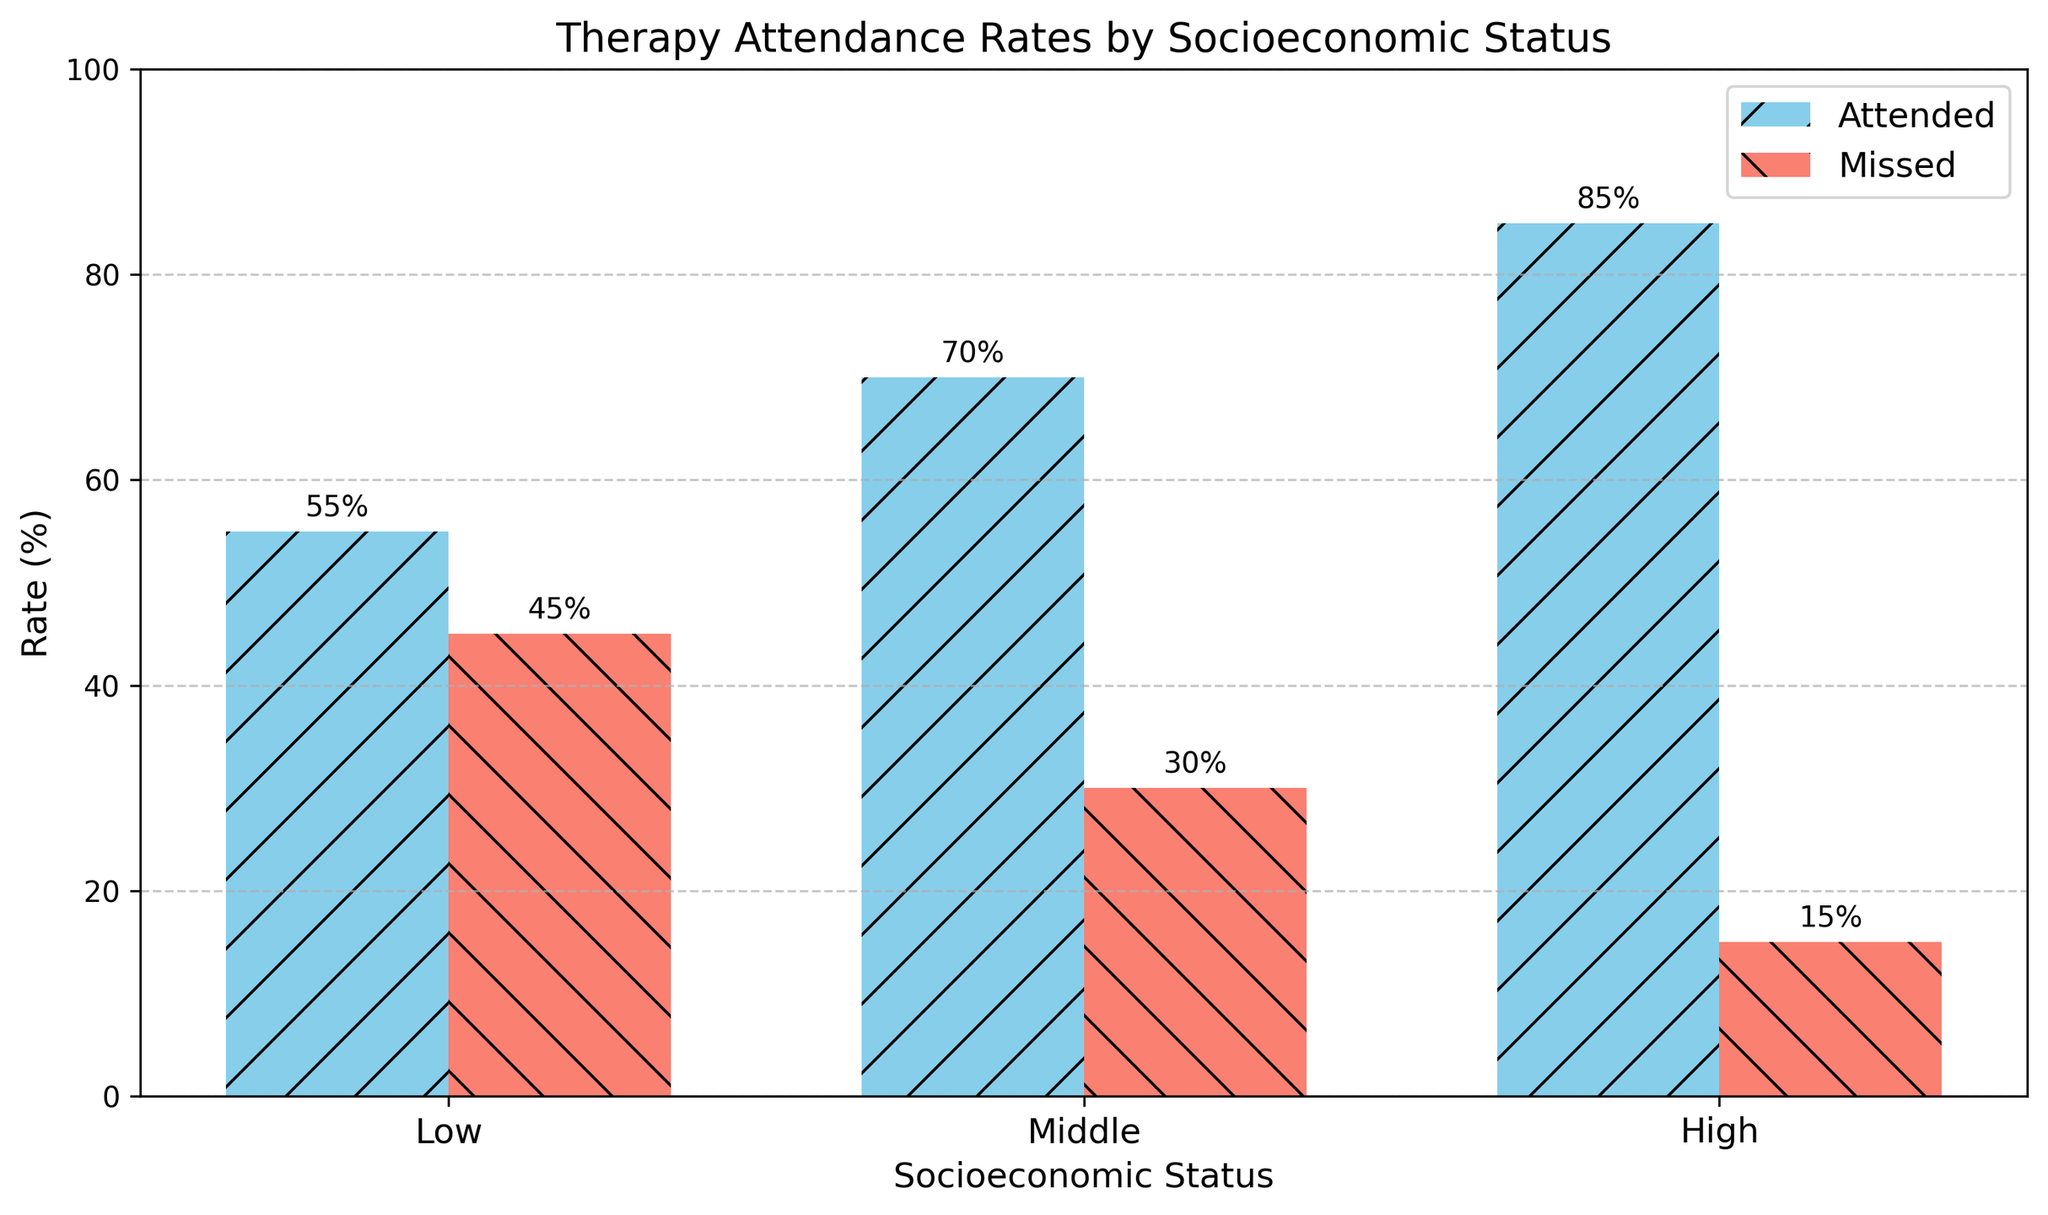What is the attendance rate for individuals from the middle socioeconomic status? The bar for the middle socioeconomic status labeled "Attended" shows a height representing the attendance rate. This value is 70%, as indicated by the data label on the bar.
Answer: 70% Which socioeconomic status group has the lowest missed therapy rate? By comparing the heights of the "Missed" bars for all socioeconomic status groups, the bar for the "High" group is the shortest, indicating the lowest missed rate.
Answer: High How much higher is the attendance rate for the high socioeconomic status group compared to the low socioeconomic status group? Subtract the attendance rate percentage of the low group from that of the high group (85% - 55%).
Answer: 30% What is the combined missed therapy rate for all socioeconomic status groups? Add the missed rates for all socioeconomic status groups: 45% (Low) + 30% (Middle) + 15% (High).
Answer: 90% What is the difference between the attendance and missed rates for the middle socioeconomic status group? Subtract the missed rate of the middle group from the attendance rate (70% - 30%).
Answer: 40% Do any socioeconomic status groups have missing rates that add up to 100% with their attendance rates? Verify for each group whether the sum of their "Attended" and "Missed" percentages equals 100% (e.g., Low: 55% + 45%, Middle: 70% + 30%, High: 85% + 15%).
Answer: Yes, all groups Which socioeconomic status has the most balanced attendance and missed rates? The group with the smallest difference between attendance and missed rates is the "Low" group (10% difference: 55% attended, 45% missed).
Answer: Low How does the attendance rate for the middle socioeconomic group compare with the missed rate for the low socioeconomic group? Observe and compare the heights of the respective bars: the "Attended" bar for the middle group is at 70%, while the "Missed" bar for the low group is at 45%.
Answer: Greater What percentage of the high socioeconomic status group did not attend therapy? The height of the "Missed" bar for the high socioeconomic status group is 15% as indicated by the data label.
Answer: 15% 